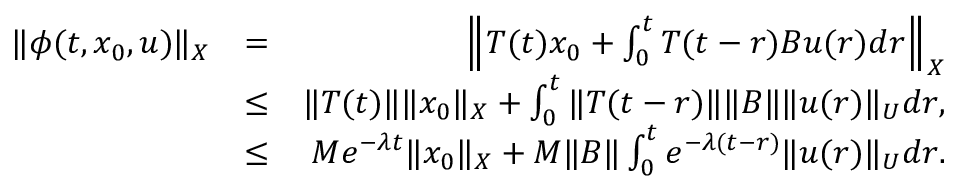Convert formula to latex. <formula><loc_0><loc_0><loc_500><loc_500>\begin{array} { r l r } { \| \phi ( t , x _ { 0 } , u ) \| _ { X } } & { = } & { \left \| T ( t ) x _ { 0 } + \int _ { 0 } ^ { t } { T ( t - r ) B u ( r ) d r } \right \| _ { X } } \\ & { \leq } & { \| T ( t ) \| \| x _ { 0 } \| _ { X } + \int _ { 0 } ^ { t } { \| T ( t - r ) \| B \| u ( r ) \| _ { U } d r } , } \\ & { \leq } & { M e ^ { - \lambda t } \| x _ { 0 } \| _ { X } + M \| B \| \int _ { 0 } ^ { t } { e ^ { - \lambda ( t - r ) } \| u ( r ) \| _ { U } d r } . } \end{array}</formula> 